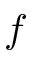Convert formula to latex. <formula><loc_0><loc_0><loc_500><loc_500>f</formula> 